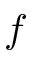Convert formula to latex. <formula><loc_0><loc_0><loc_500><loc_500>f</formula> 